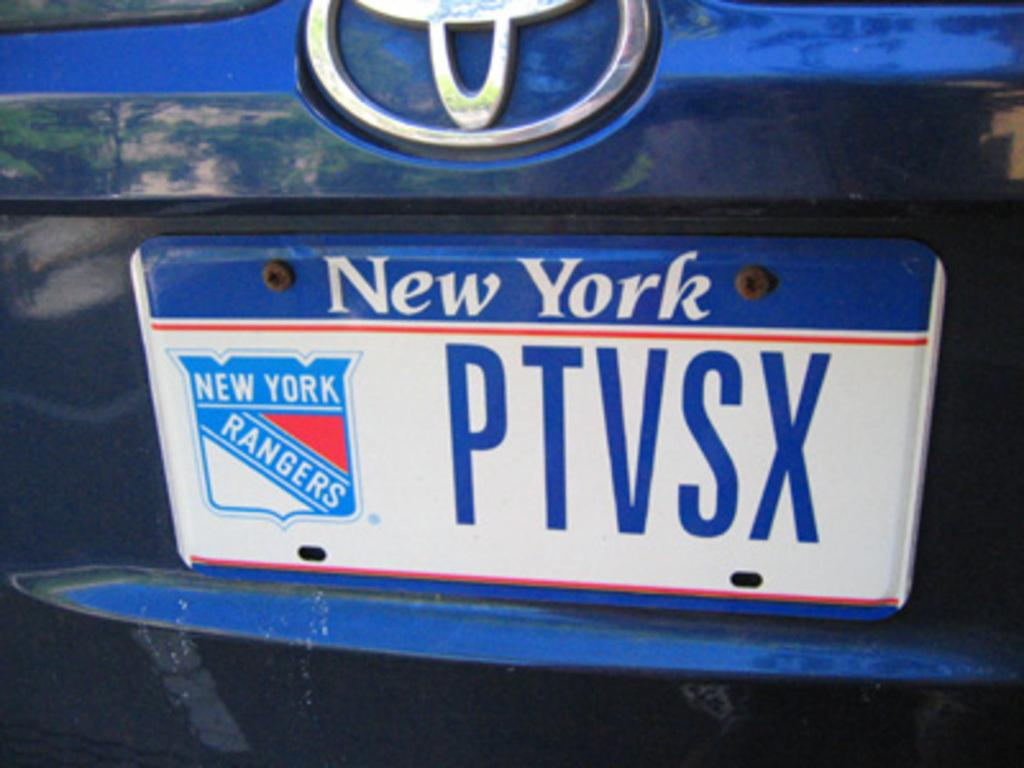<image>
Describe the image concisely. The driver of this car is a New York Rangers fan. 